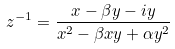Convert formula to latex. <formula><loc_0><loc_0><loc_500><loc_500>z ^ { - 1 } = \frac { x - \beta y - i y } { x ^ { 2 } - \beta x y + \alpha y ^ { 2 } }</formula> 